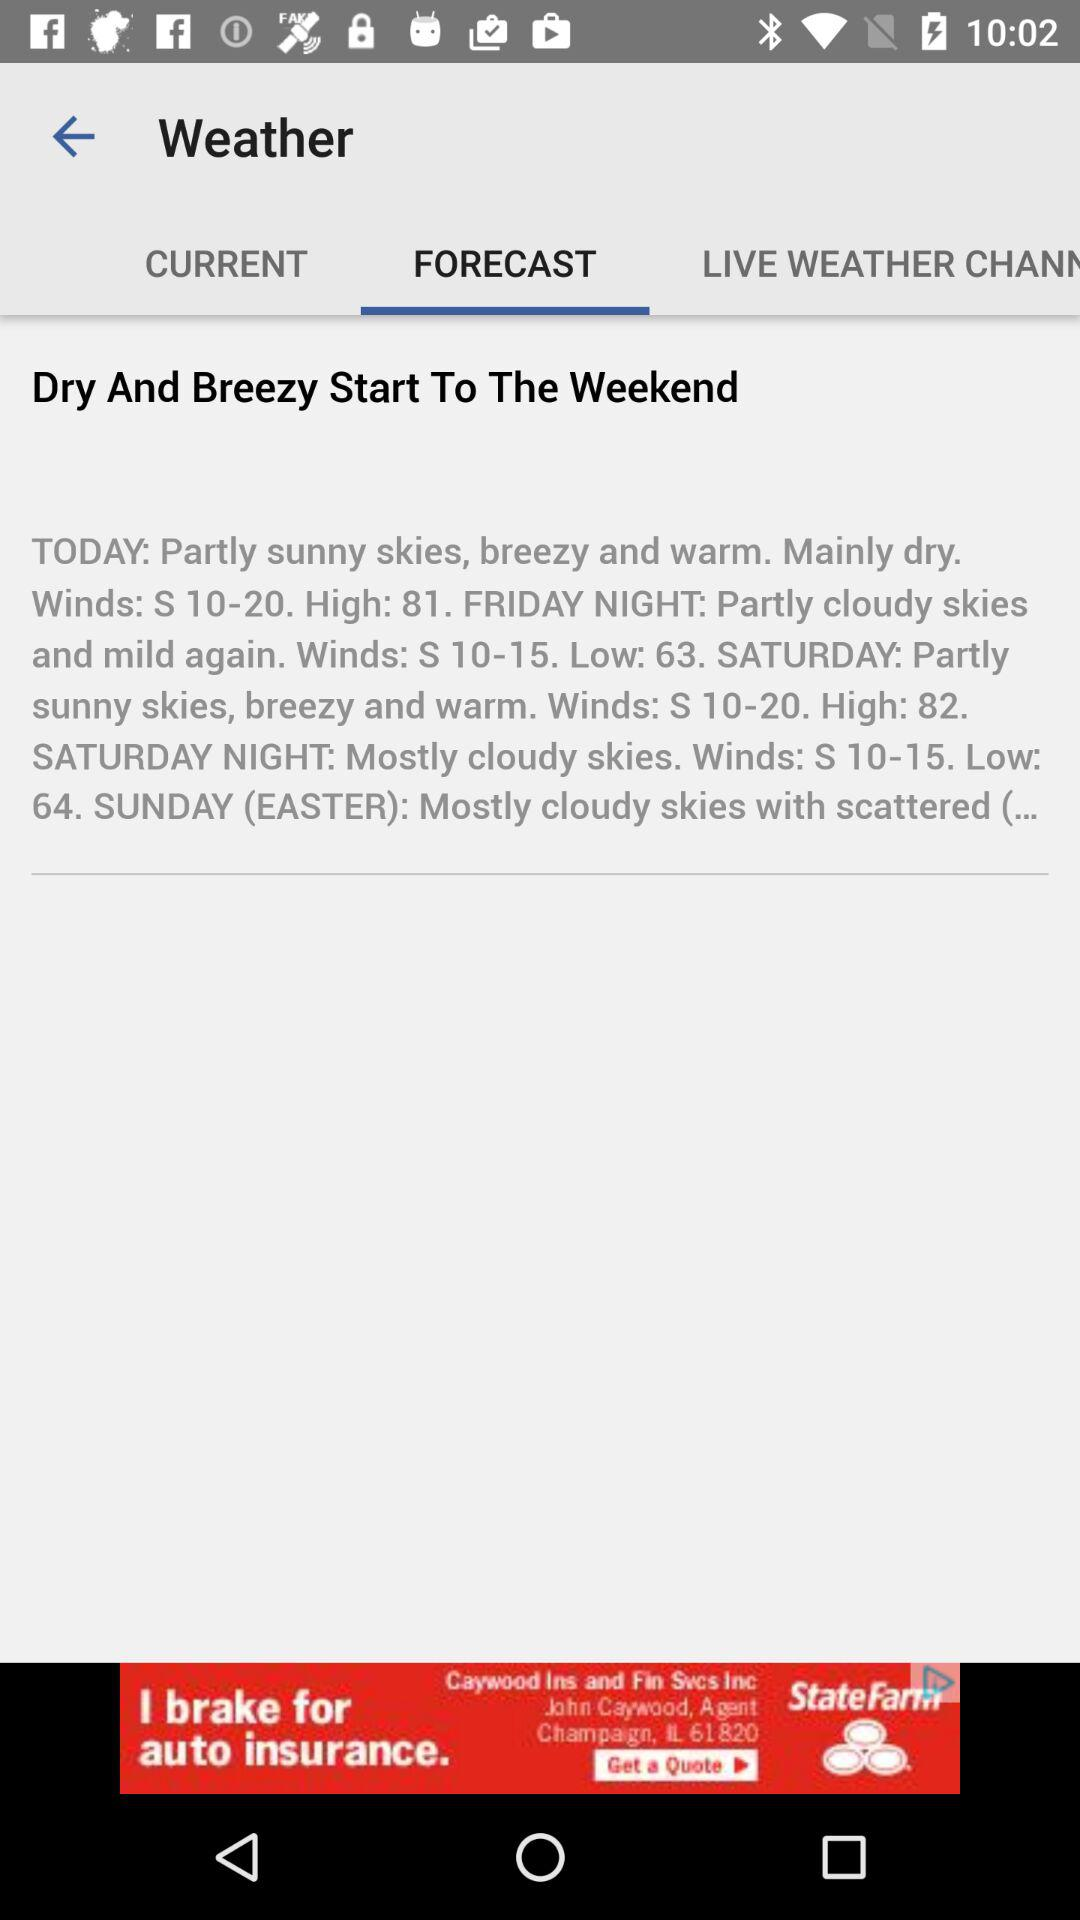Which tab has been selected? The selected tab is Forecast. 